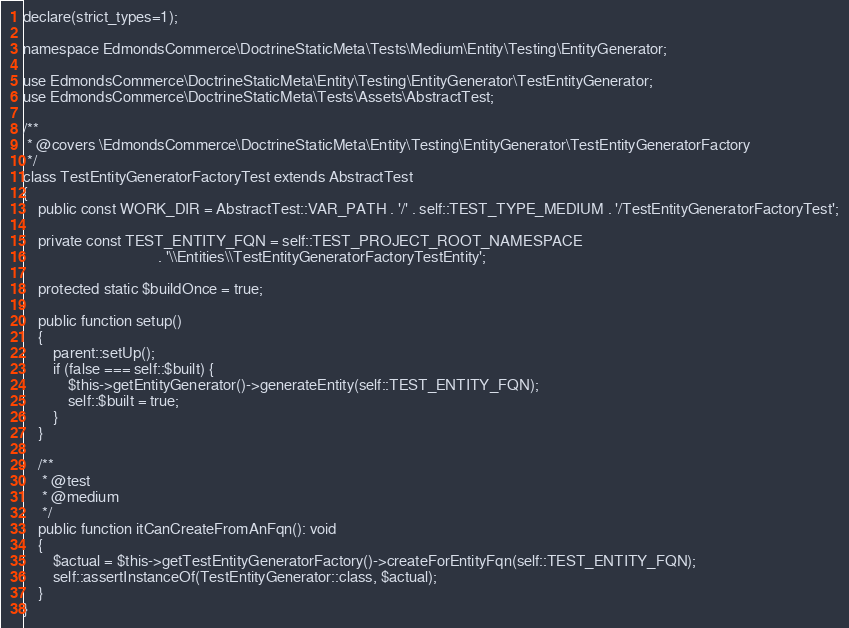<code> <loc_0><loc_0><loc_500><loc_500><_PHP_>
declare(strict_types=1);

namespace EdmondsCommerce\DoctrineStaticMeta\Tests\Medium\Entity\Testing\EntityGenerator;

use EdmondsCommerce\DoctrineStaticMeta\Entity\Testing\EntityGenerator\TestEntityGenerator;
use EdmondsCommerce\DoctrineStaticMeta\Tests\Assets\AbstractTest;

/**
 * @covers \EdmondsCommerce\DoctrineStaticMeta\Entity\Testing\EntityGenerator\TestEntityGeneratorFactory
 */
class TestEntityGeneratorFactoryTest extends AbstractTest
{
    public const WORK_DIR = AbstractTest::VAR_PATH . '/' . self::TEST_TYPE_MEDIUM . '/TestEntityGeneratorFactoryTest';

    private const TEST_ENTITY_FQN = self::TEST_PROJECT_ROOT_NAMESPACE
                                    . '\\Entities\\TestEntityGeneratorFactoryTestEntity';

    protected static $buildOnce = true;

    public function setup()
    {
        parent::setUp();
        if (false === self::$built) {
            $this->getEntityGenerator()->generateEntity(self::TEST_ENTITY_FQN);
            self::$built = true;
        }
    }

    /**
     * @test
     * @medium
     */
    public function itCanCreateFromAnFqn(): void
    {
        $actual = $this->getTestEntityGeneratorFactory()->createForEntityFqn(self::TEST_ENTITY_FQN);
        self::assertInstanceOf(TestEntityGenerator::class, $actual);
    }
}
</code> 